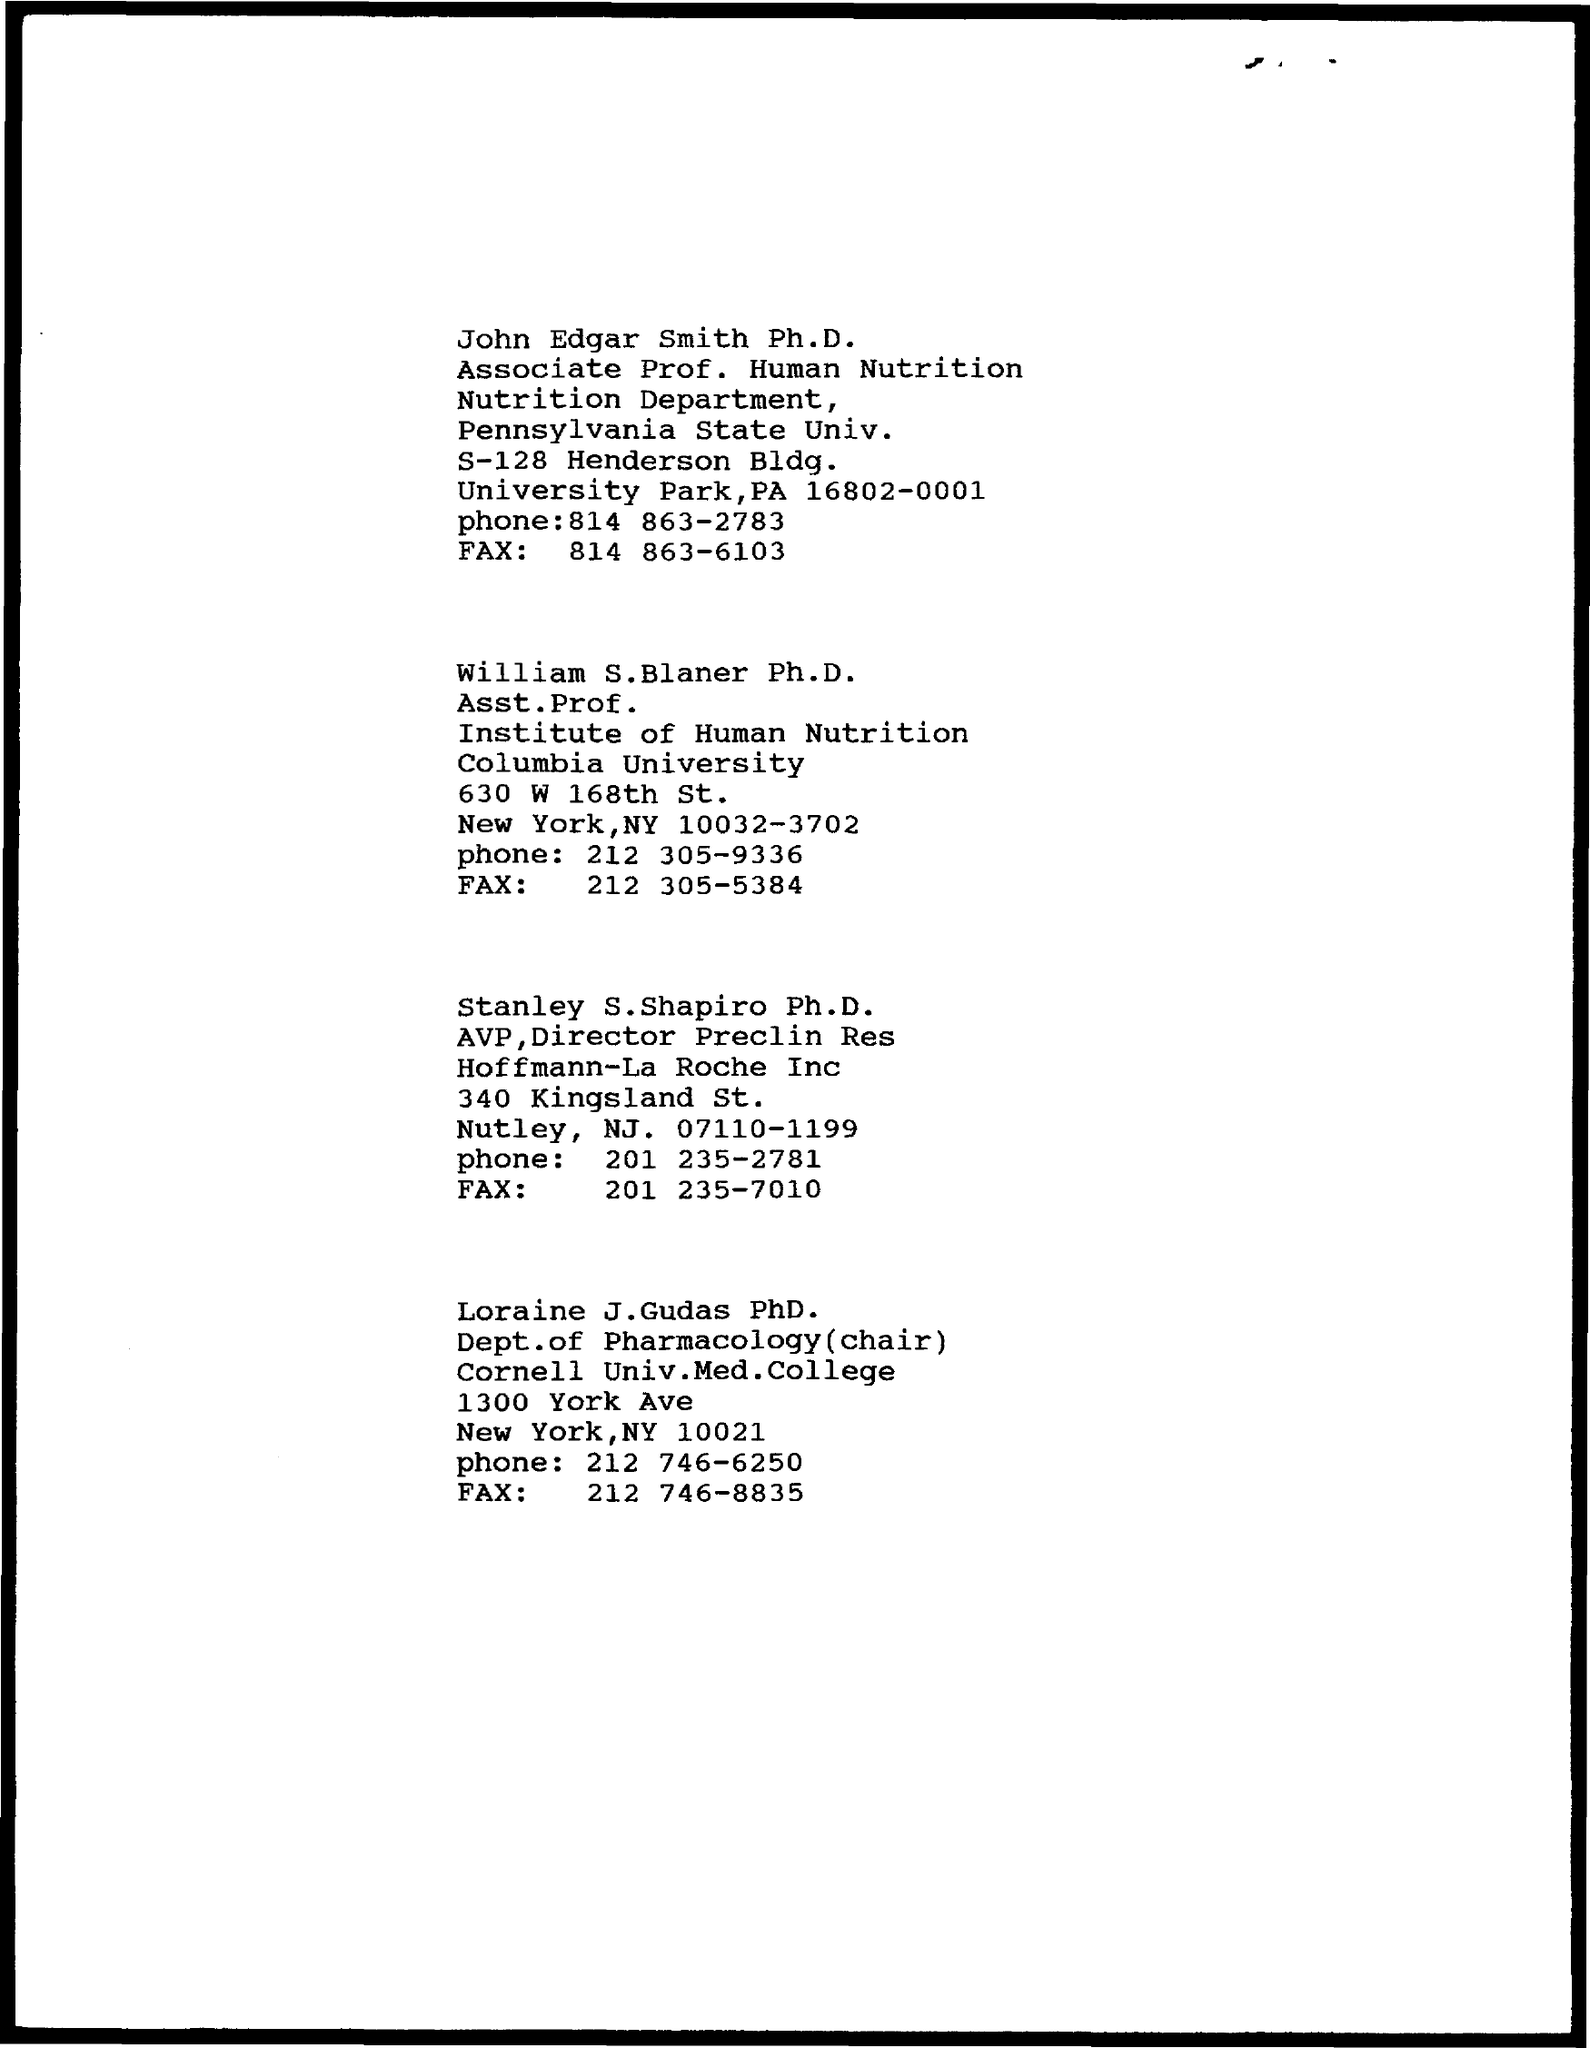To which university does william s. blaner belong to?
Make the answer very short. Columbia University. 